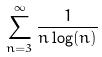<formula> <loc_0><loc_0><loc_500><loc_500>\sum _ { n = 3 } ^ { \infty } \frac { 1 } { n \log ( n ) }</formula> 